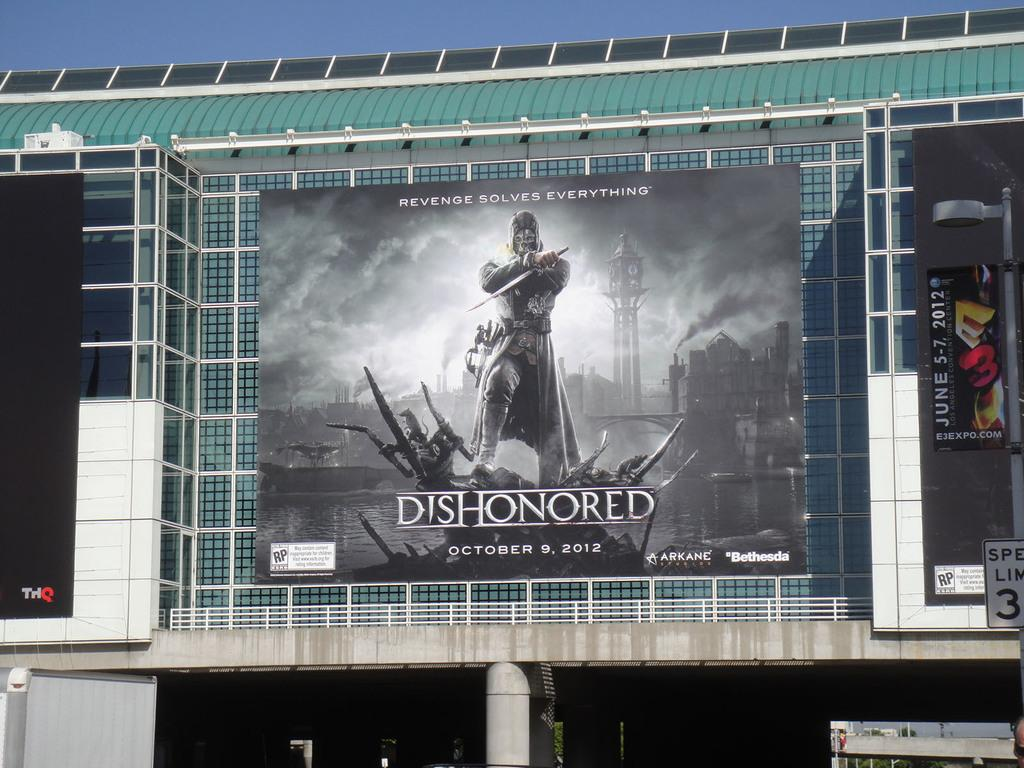What type of signage is present in the image? There are hoardings in the image. What objects can be seen on the hoardings? The provided facts do not mention any specific objects on the hoardings. What can be seen in the background of the image? The sky is visible in the background of the image. Are there any objects related to drinking or serving beverages in the image? Yes, there are glasses in the image. What type of son is depicted on the hoardings in the image? There is no son depicted on the hoardings in the image. What type of system is used to support the glasses in the image? The provided facts do not mention any specific system used to support the glasses in the image. 